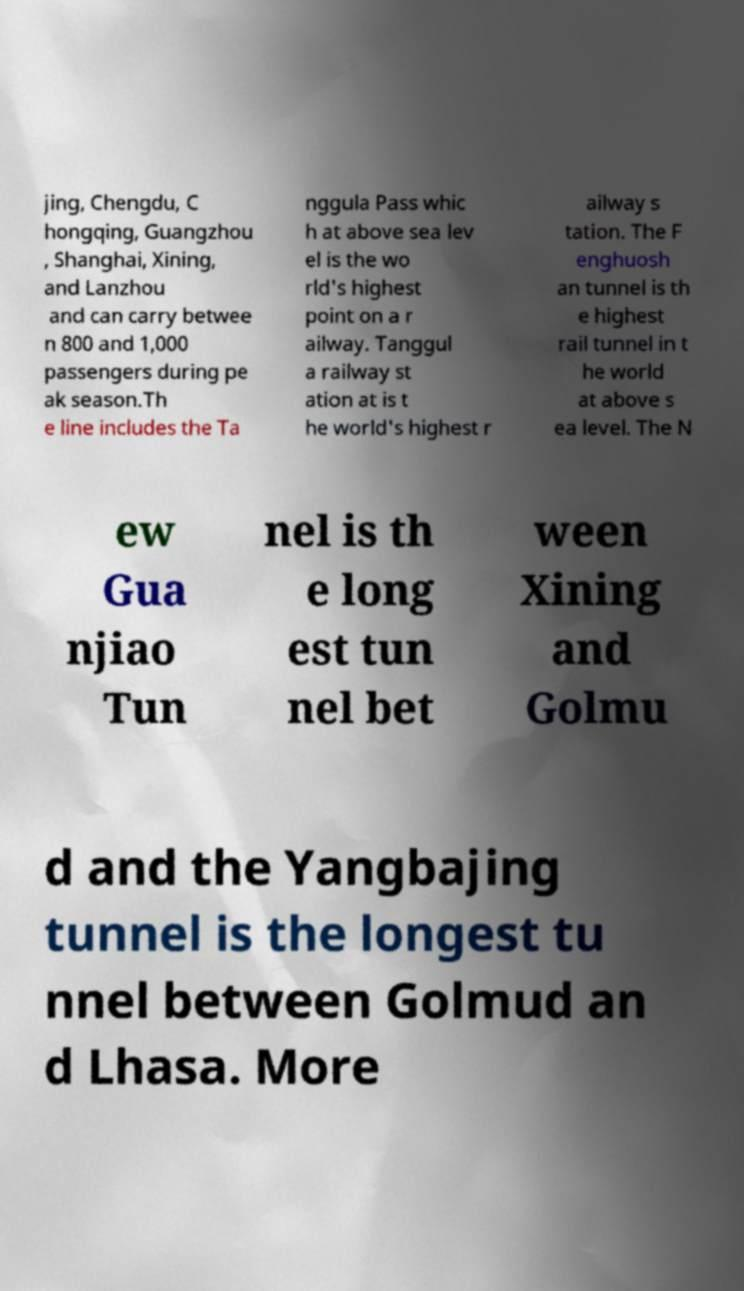Could you extract and type out the text from this image? jing, Chengdu, C hongqing, Guangzhou , Shanghai, Xining, and Lanzhou and can carry betwee n 800 and 1,000 passengers during pe ak season.Th e line includes the Ta nggula Pass whic h at above sea lev el is the wo rld's highest point on a r ailway. Tanggul a railway st ation at is t he world's highest r ailway s tation. The F enghuosh an tunnel is th e highest rail tunnel in t he world at above s ea level. The N ew Gua njiao Tun nel is th e long est tun nel bet ween Xining and Golmu d and the Yangbajing tunnel is the longest tu nnel between Golmud an d Lhasa. More 